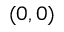Convert formula to latex. <formula><loc_0><loc_0><loc_500><loc_500>( 0 , 0 )</formula> 